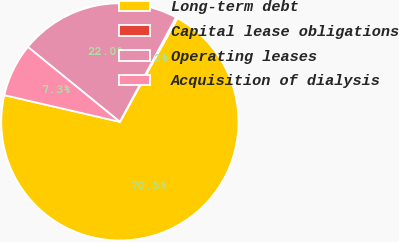Convert chart. <chart><loc_0><loc_0><loc_500><loc_500><pie_chart><fcel>Long-term debt<fcel>Capital lease obligations<fcel>Operating leases<fcel>Acquisition of dialysis<nl><fcel>70.54%<fcel>0.23%<fcel>21.96%<fcel>7.26%<nl></chart> 